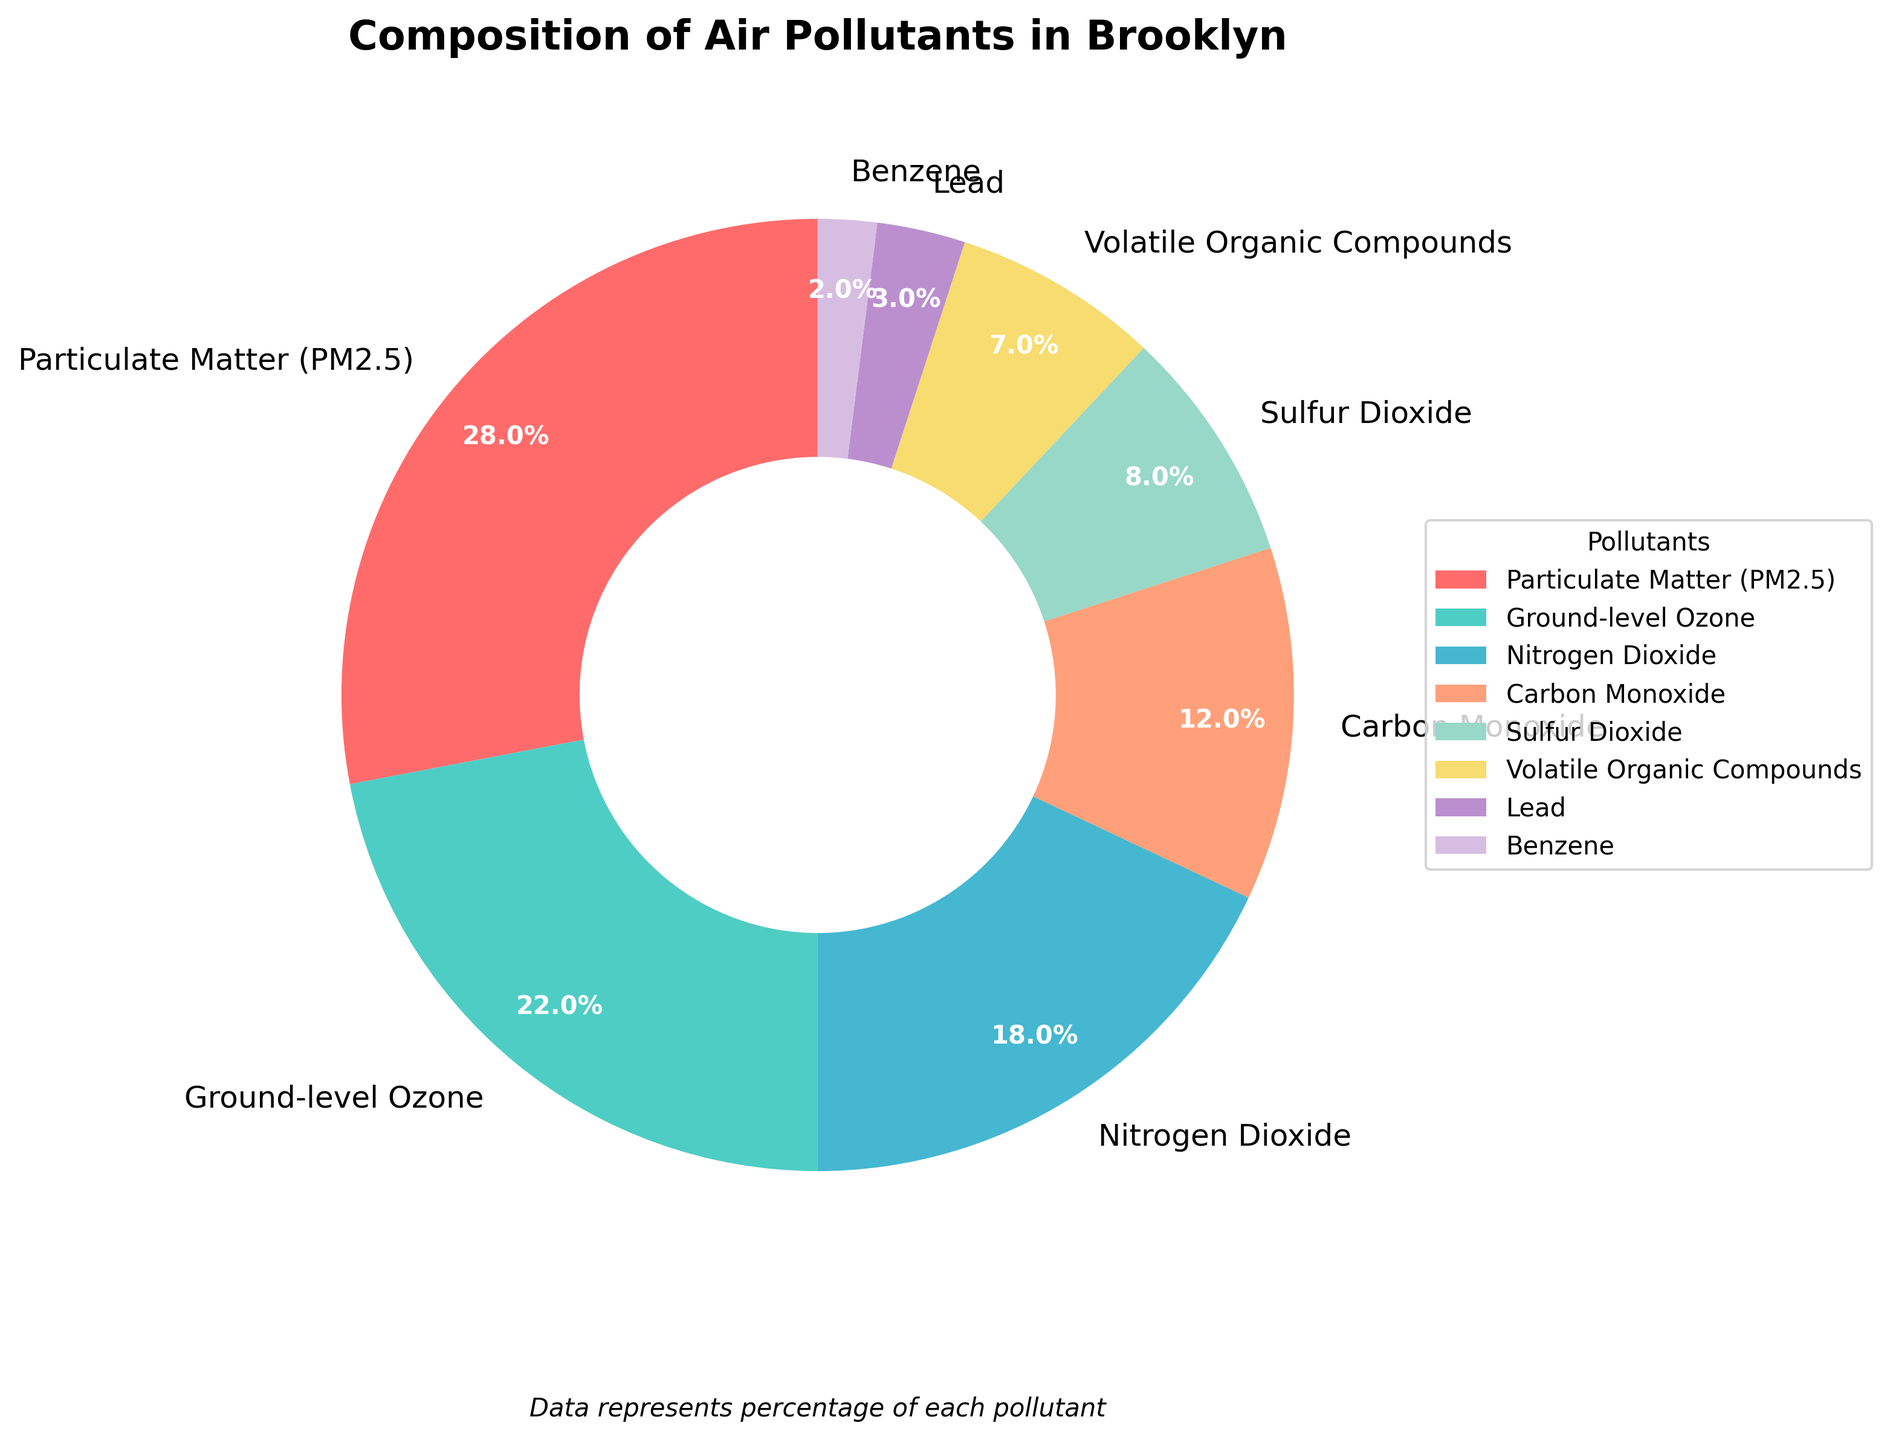What's the largest pollutant by percentage? From the pie chart, the section representing "Particulate Matter (PM2.5)" is the largest, which has a percentage label of 28%.
Answer: Particulate Matter (PM2.5) What is the combined percentage of Nitrogen Dioxide and Carbon Monoxide? According to the pie chart, Nitrogen Dioxide is 18% and Carbon Monoxide is 12%. Adding these gives 18 + 12 = 30%.
Answer: 30% Which two pollutants have a combined percentage equal to Ground-level Ozone? Ground-level Ozone is 22% according to the chart. Combining Sulfur Dioxide (8%) and Volatile Organic Compounds (7%) gives 8 + 7 = 15%. Therefore, these two combined do not equal Ground-level Ozone. The correct combination is Carbon Monoxide (12%) and Benzene (10%), giving 12 + 10 = 22%.
Answer: Carbon Monoxide and Benzene Which pollutants have percentages less than 10%? The pie chart shows that Sulfur Dioxide (8%), Volatile Organic Compounds (7%), Lead (3%), and Benzene (2%) all have percentages less than 10%.
Answer: Sulfur Dioxide, Volatile Organic Compounds, Lead, Benzene Which section of the pie chart is colored blue? The pie chart should be inspected to identify the section filled with blue, which corresponds to Ground-level Ozone at 22%.
Answer: Ground-level Ozone What is the difference in percentage between Particulate Matter (PM2.5) and Carbon Monoxide? Particulate Matter (PM2.5) is 28%, and Carbon Monoxide is 12%. Therefore, the difference is 28 - 12 = 16%.
Answer: 16% How do Volatile Organic Compounds compare to Nitrogen Dioxide in terms of percentage? From the pie chart, Volatile Organic Compounds have 7%, whereas Nitrogen Dioxide has 18%. Volatile Organic Compounds have a smaller percentage.
Answer: Volatile Organic Compounds have a smaller percentage What is the second smallest pollutant by percentage? Observing the pie chart shows that after Benzene (2%), the second smallest is Lead at 3%.
Answer: Lead Sum up the percentages of all the pollutants with a two-digit percentage figure. The two-digit percentage figures are Particulate Matter (PM2.5) at 28%, Ground-level Ozone at 22%, and Nitrogen Dioxide at 18%. Adding these gives 28 + 22 + 18 = 68%.
Answer: 68% What average percentage do the pollutants with a percentage of less than 10% contribute? The pollutants with less than 10% are Sulfur Dioxide (8%), Volatile Organic Compounds (7%), Lead (3%), and Benzene (2%). Adding these gives 8 + 7 + 3 + 2 = 20%. The number of pollutants is 4, so the average is 20 / 4 = 5%.
Answer: 5% 